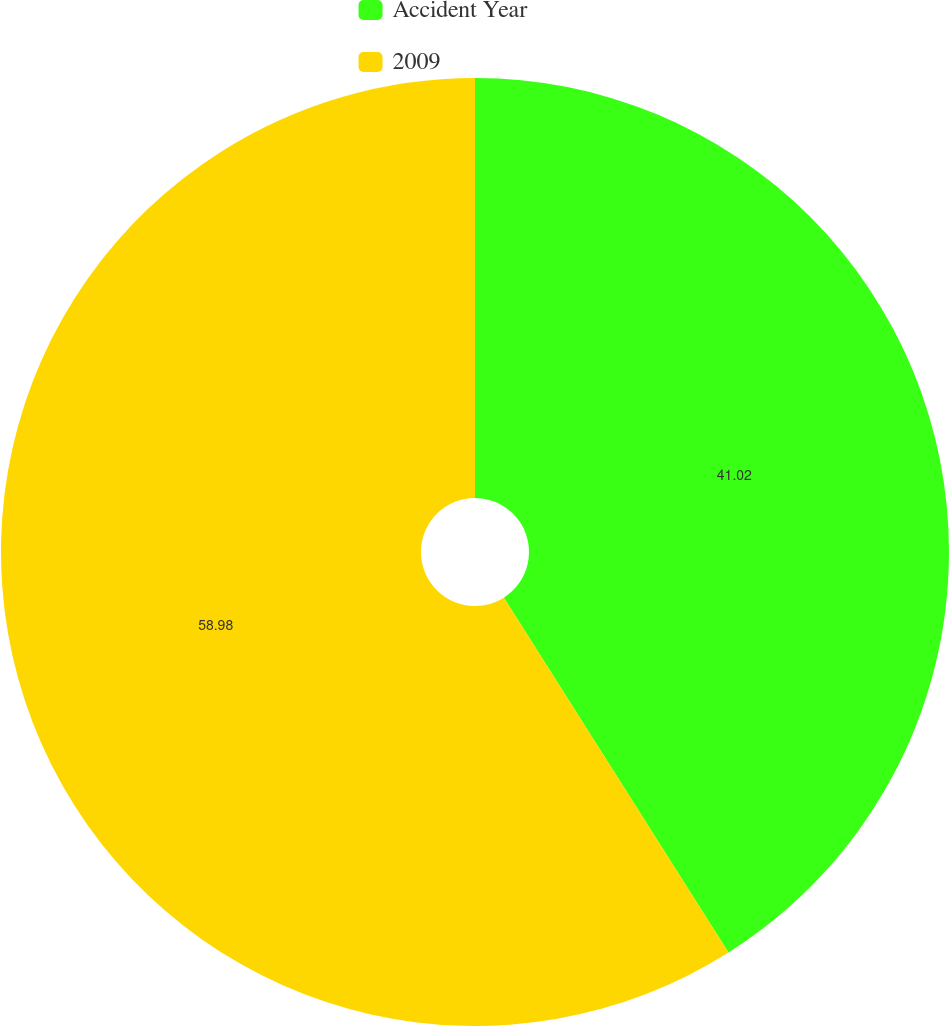<chart> <loc_0><loc_0><loc_500><loc_500><pie_chart><fcel>Accident Year<fcel>2009<nl><fcel>41.02%<fcel>58.98%<nl></chart> 